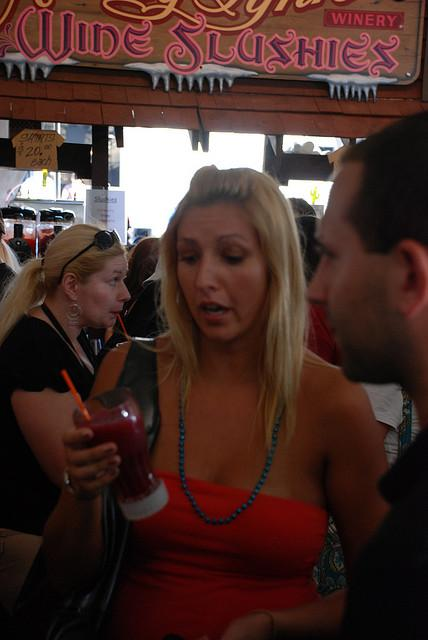Where are these people located?

Choices:
A) library
B) hospital
C) school
D) winery winery 